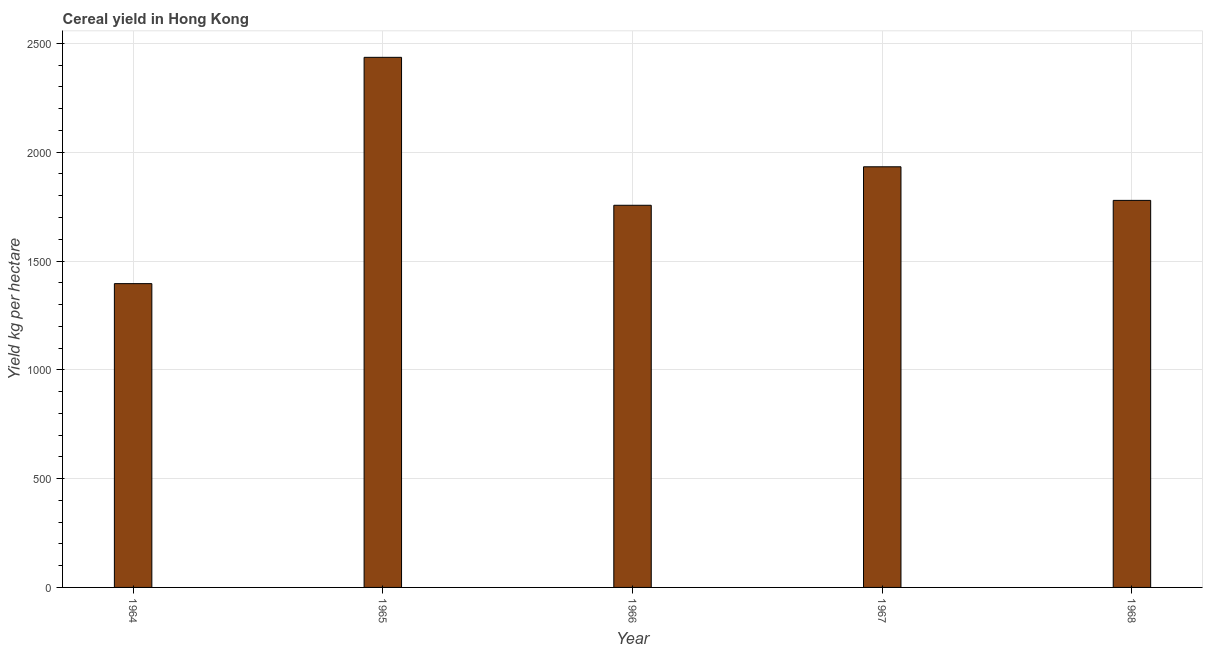Does the graph contain any zero values?
Ensure brevity in your answer.  No. What is the title of the graph?
Your answer should be very brief. Cereal yield in Hong Kong. What is the label or title of the Y-axis?
Offer a very short reply. Yield kg per hectare. What is the cereal yield in 1966?
Your response must be concise. 1756.26. Across all years, what is the maximum cereal yield?
Offer a very short reply. 2436.17. Across all years, what is the minimum cereal yield?
Keep it short and to the point. 1396.16. In which year was the cereal yield maximum?
Ensure brevity in your answer.  1965. In which year was the cereal yield minimum?
Your answer should be compact. 1964. What is the sum of the cereal yield?
Your answer should be very brief. 9300.4. What is the difference between the cereal yield in 1964 and 1965?
Your response must be concise. -1040.01. What is the average cereal yield per year?
Your response must be concise. 1860.08. What is the median cereal yield?
Your answer should be very brief. 1778.7. In how many years, is the cereal yield greater than 1100 kg per hectare?
Offer a very short reply. 5. What is the ratio of the cereal yield in 1966 to that in 1968?
Your response must be concise. 0.99. Is the cereal yield in 1964 less than that in 1965?
Your response must be concise. Yes. What is the difference between the highest and the second highest cereal yield?
Your answer should be very brief. 503.06. What is the difference between the highest and the lowest cereal yield?
Give a very brief answer. 1040.01. In how many years, is the cereal yield greater than the average cereal yield taken over all years?
Offer a very short reply. 2. How many bars are there?
Offer a very short reply. 5. What is the difference between two consecutive major ticks on the Y-axis?
Offer a very short reply. 500. What is the Yield kg per hectare in 1964?
Provide a short and direct response. 1396.16. What is the Yield kg per hectare in 1965?
Ensure brevity in your answer.  2436.17. What is the Yield kg per hectare in 1966?
Your answer should be compact. 1756.26. What is the Yield kg per hectare of 1967?
Give a very brief answer. 1933.11. What is the Yield kg per hectare in 1968?
Keep it short and to the point. 1778.7. What is the difference between the Yield kg per hectare in 1964 and 1965?
Your response must be concise. -1040.01. What is the difference between the Yield kg per hectare in 1964 and 1966?
Make the answer very short. -360.1. What is the difference between the Yield kg per hectare in 1964 and 1967?
Keep it short and to the point. -536.95. What is the difference between the Yield kg per hectare in 1964 and 1968?
Provide a succinct answer. -382.55. What is the difference between the Yield kg per hectare in 1965 and 1966?
Make the answer very short. 679.91. What is the difference between the Yield kg per hectare in 1965 and 1967?
Ensure brevity in your answer.  503.06. What is the difference between the Yield kg per hectare in 1965 and 1968?
Keep it short and to the point. 657.46. What is the difference between the Yield kg per hectare in 1966 and 1967?
Ensure brevity in your answer.  -176.85. What is the difference between the Yield kg per hectare in 1966 and 1968?
Offer a very short reply. -22.45. What is the difference between the Yield kg per hectare in 1967 and 1968?
Keep it short and to the point. 154.41. What is the ratio of the Yield kg per hectare in 1964 to that in 1965?
Ensure brevity in your answer.  0.57. What is the ratio of the Yield kg per hectare in 1964 to that in 1966?
Offer a very short reply. 0.8. What is the ratio of the Yield kg per hectare in 1964 to that in 1967?
Offer a terse response. 0.72. What is the ratio of the Yield kg per hectare in 1964 to that in 1968?
Keep it short and to the point. 0.79. What is the ratio of the Yield kg per hectare in 1965 to that in 1966?
Your answer should be very brief. 1.39. What is the ratio of the Yield kg per hectare in 1965 to that in 1967?
Make the answer very short. 1.26. What is the ratio of the Yield kg per hectare in 1965 to that in 1968?
Provide a succinct answer. 1.37. What is the ratio of the Yield kg per hectare in 1966 to that in 1967?
Your response must be concise. 0.91. What is the ratio of the Yield kg per hectare in 1967 to that in 1968?
Offer a very short reply. 1.09. 